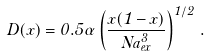<formula> <loc_0><loc_0><loc_500><loc_500>D ( x ) = 0 . 5 \alpha \left ( \frac { x ( 1 - x ) } { N a _ { e x } ^ { 3 } } \right ) ^ { 1 / 2 } \, .</formula> 